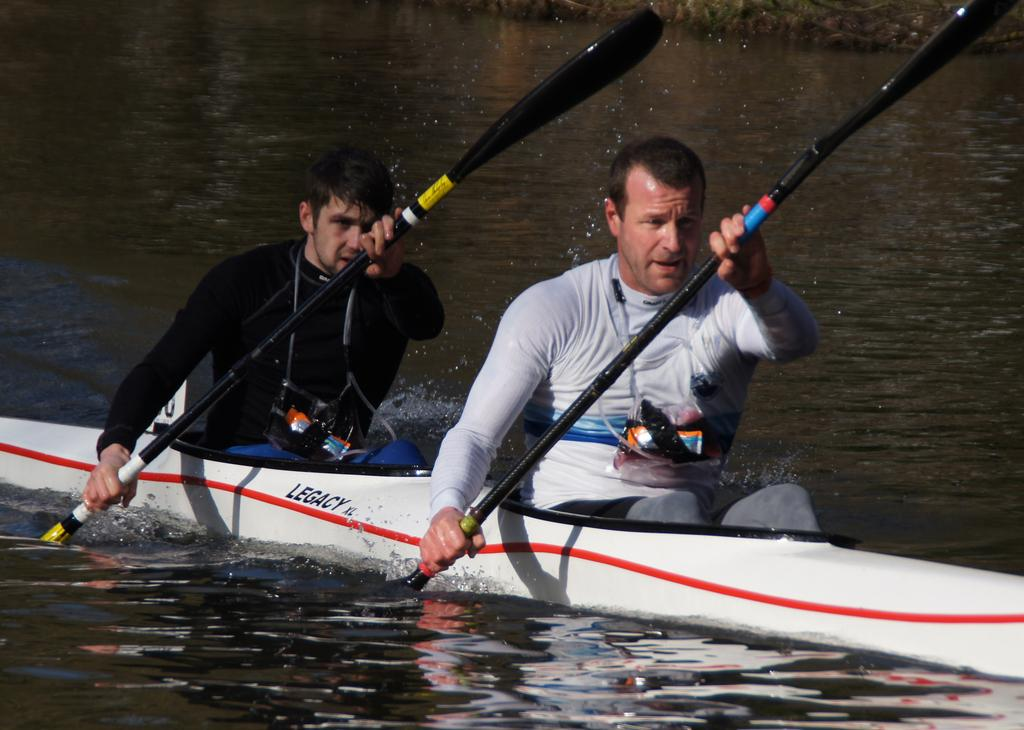What is the main subject in the center of the image? There is a boat in the center of the image. Who is in the boat? There are two people sitting in the boat. What are the people doing in the boat? The people are holding rows in their hands. What can be seen at the bottom of the image? There is water visible at the bottom of the image. What type of vest is the person in the front of the boat wearing? There is no vest visible on either person in the boat. 